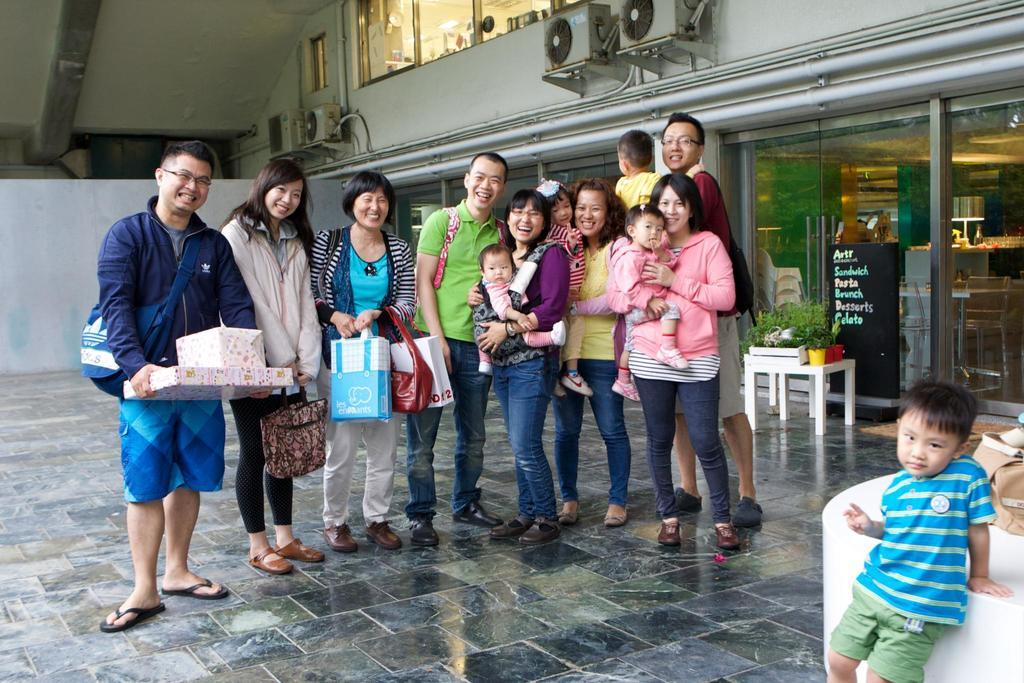What is happening with the group of people in the image? The people in the image are standing and smiling. What can be seen on the table in the image? There are plants on a table in the image. What type of appliances are visible in the image? There are air conditioners in the image. What is the purpose of the board in the image? The purpose of the board in the image is not clear from the provided facts. What type of wine is being served to the people in the image? There is no wine present in the image. How does the yam contribute to the wealth of the people in the image? There is no yam or mention of wealth in the image. 